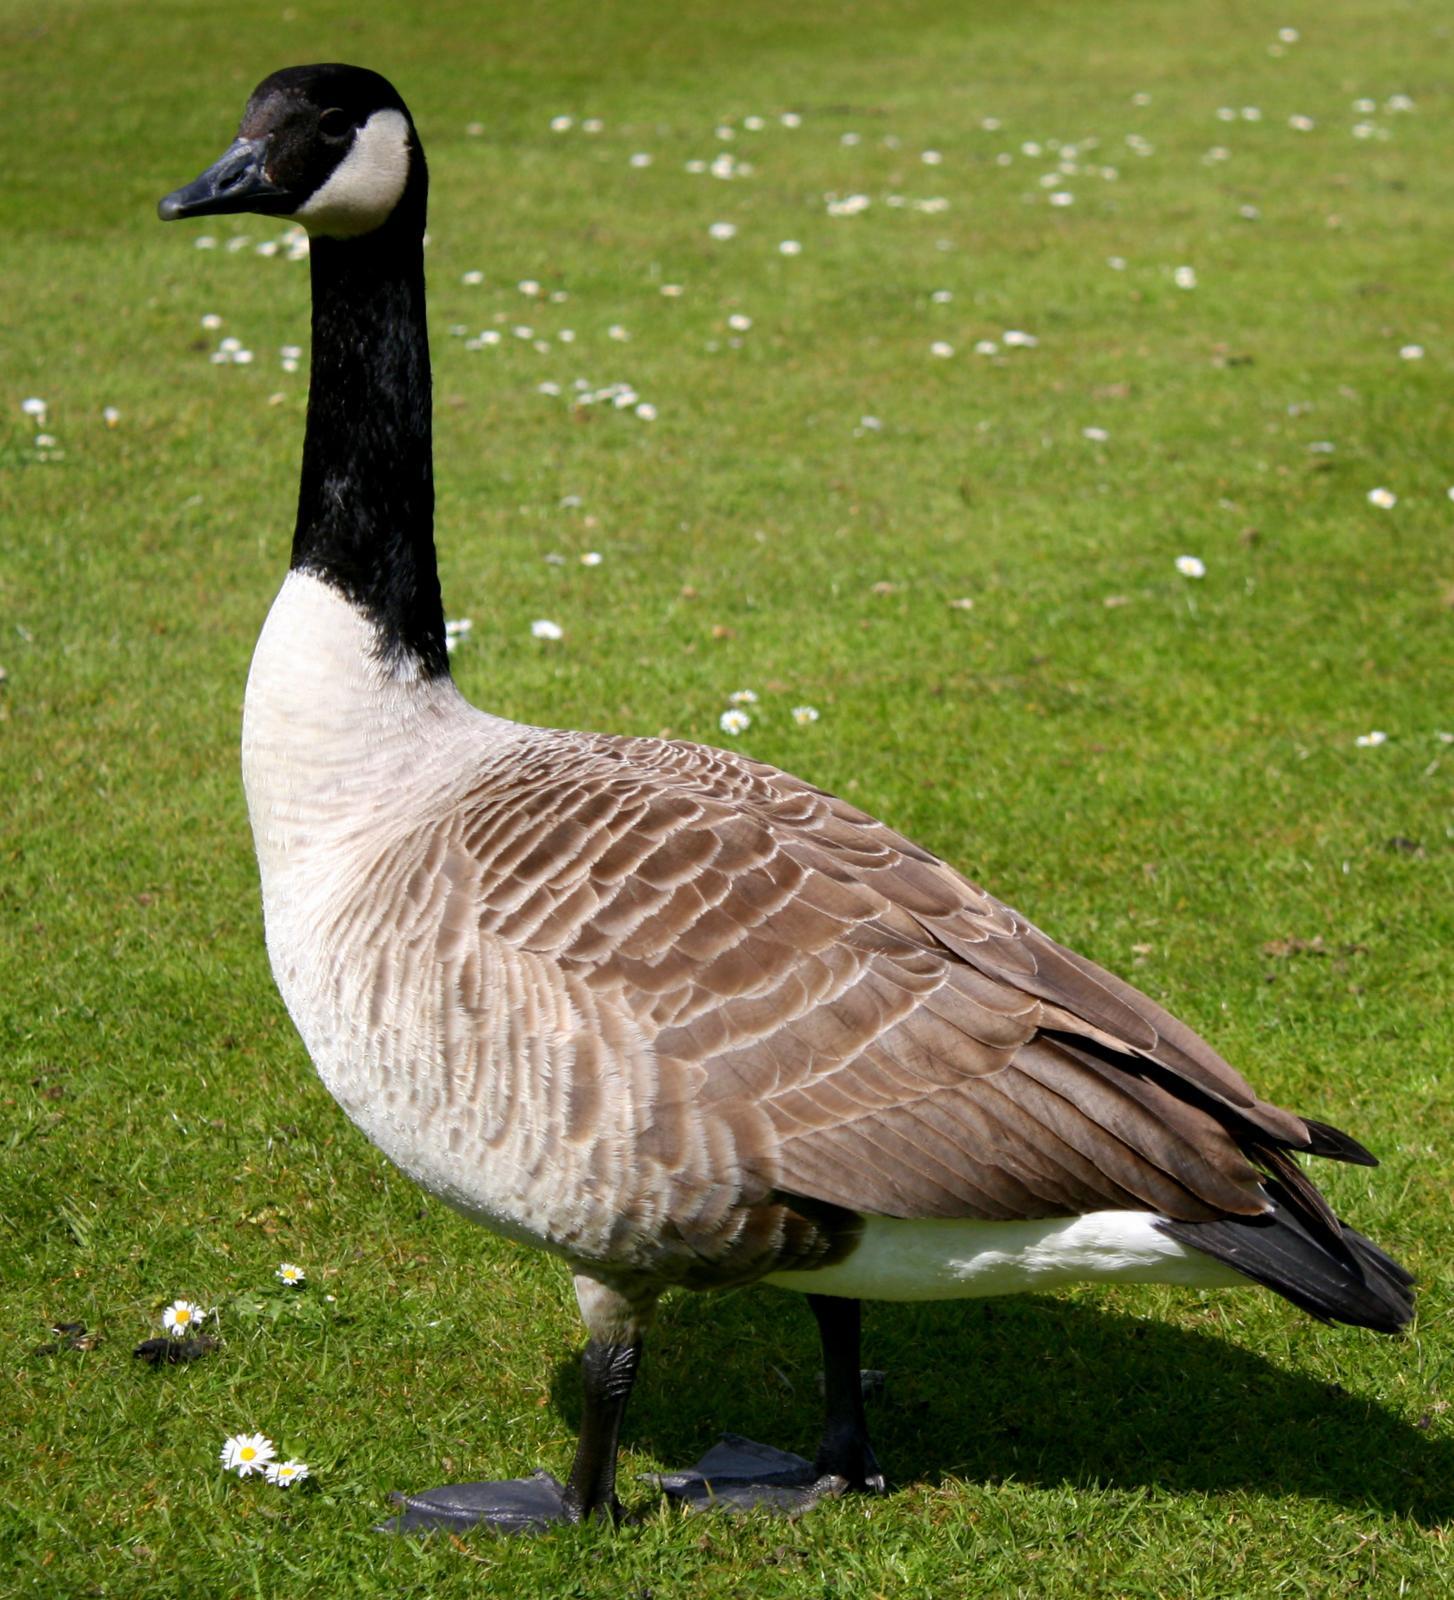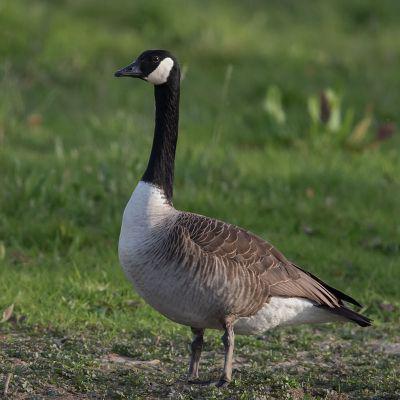The first image is the image on the left, the second image is the image on the right. Given the left and right images, does the statement "Only geese with black and white faces are shown." hold true? Answer yes or no. Yes. 